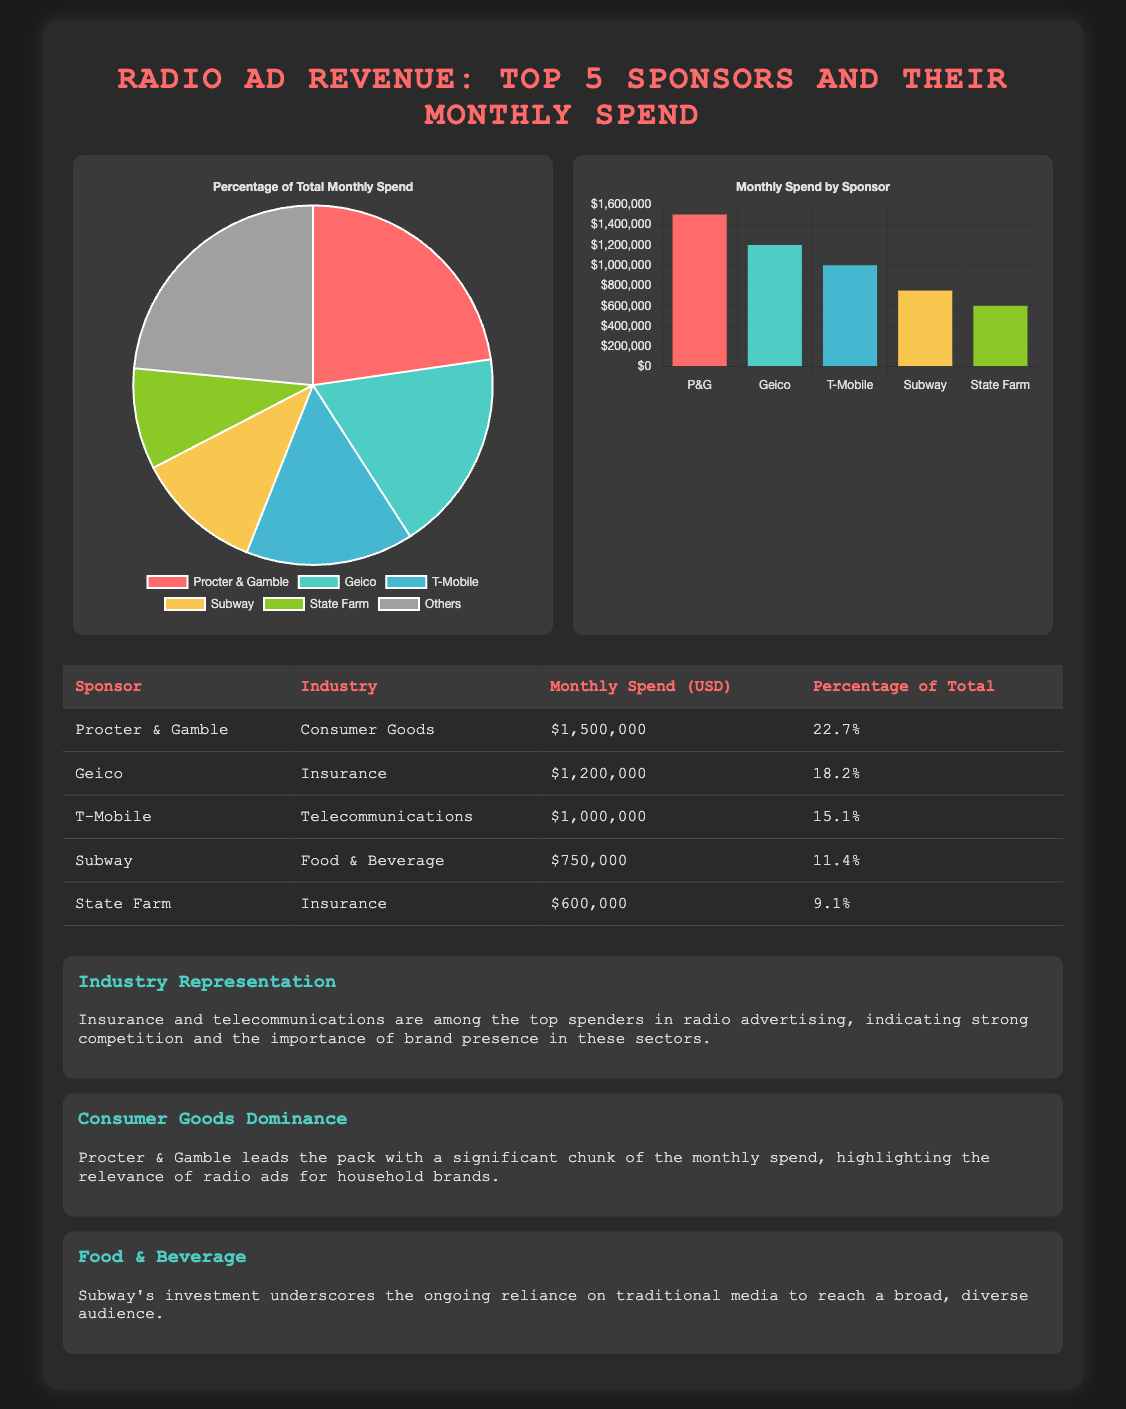What is the highest monthly spend among the sponsors? The highest monthly spend is for Procter & Gamble at $1,500,000.
Answer: $1,500,000 Which industry does T-Mobile belong to? T-Mobile is classified under the Telecommunications industry.
Answer: Telecommunications What percentage of total monthly spend does State Farm account for? State Farm accounts for 9.1% of the total monthly spend.
Answer: 9.1% How much does Subway spend monthly on advertising? Subway spends $750,000 monthly on advertising.
Answer: $750,000 How many sponsors are listed in the document? There are five sponsors listed in the document.
Answer: Five Which sponsor has the lowest ad expenditure? State Farm has the lowest ad expenditure at $600,000.
Answer: State Farm What color represents Geico in the charts? Geico is represented by the color teal in the charts.
Answer: Teal What type of chart shows the percentage of total monthly spend? A pie chart displays the percentage of total monthly spend.
Answer: Pie chart How is the monthly spend categorized in the bar chart? The bar chart categorizes monthly spend by sponsor name.
Answer: By sponsor name 